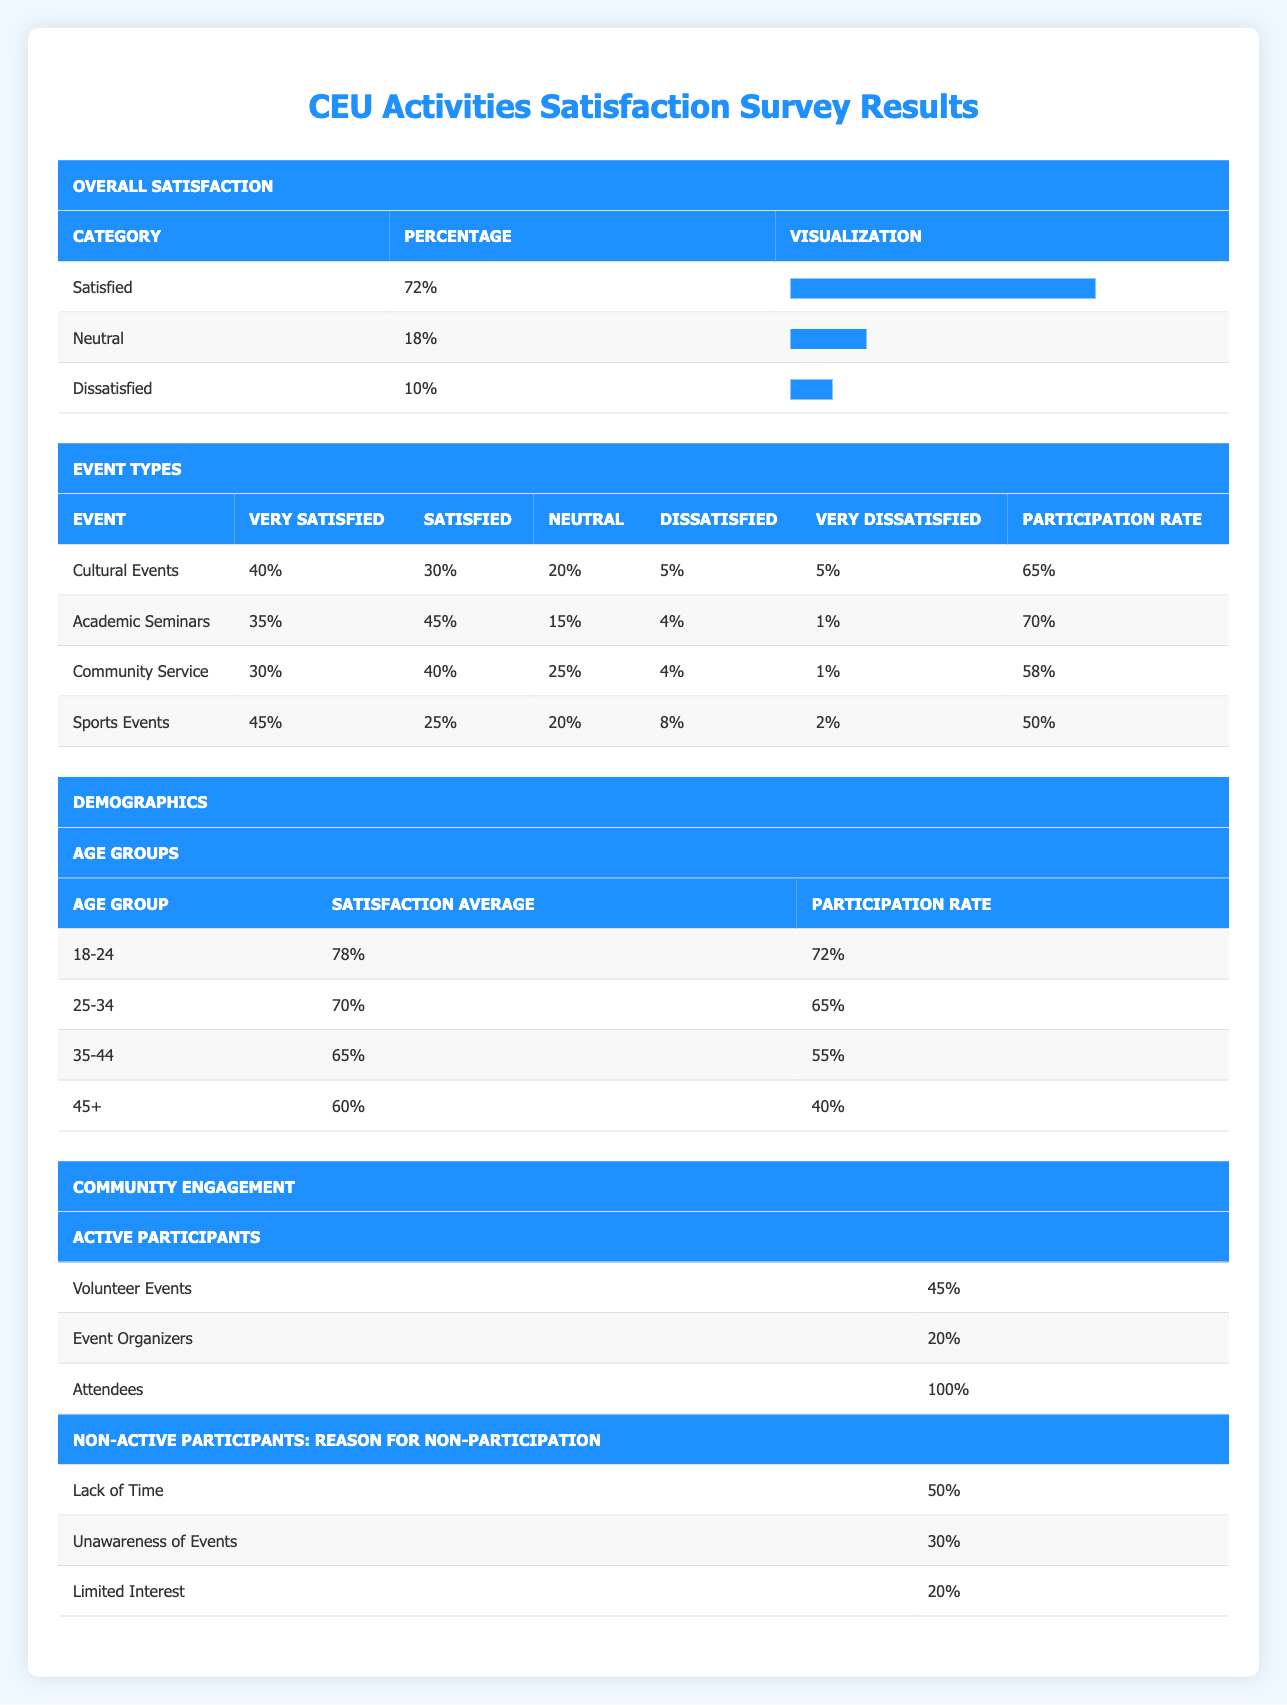What percentage of respondents were satisfied with CEU activities? According to the Overall Satisfaction section of the table, 72% of respondents reported being satisfied.
Answer: 72% What is the participation rate for Cultural Events? The Participation Rate for Cultural Events is listed as 65%.
Answer: 65% What is the average satisfaction for the 18-24 age group? The Satisfaction Average for the 18-24 age group is 78%, as stated under the Age Groups section.
Answer: 78% For which event type is the dissatisfaction percentage lowest? The Academic Seminars have the lowest dissatisfaction percentage at 5% (4% dissatisfied and 1% very dissatisfied).
Answer: Academic Seminars Is the participation rate for the 45+ age group higher than that for the 35-44 age group? The participation rate for the 45+ age group is 40%, while for the 35-44 age group, it is 55%. Therefore, the 45+ age group's participation rate is lower.
Answer: No What is the difference in the average satisfaction between the 18-24 age group and the 35-44 age group? The average satisfaction for the 18-24 age group is 78% and for the 35-44 age group is 65%. The difference is 78% - 65% = 13%.
Answer: 13% How many respondents cited 'Lack of Time' as the reason for non-participation? The Non-Active Participants section indicates that 50% cited 'Lack of Time' as the reason for not participating.
Answer: 50% What is the total participation rate of all active participants combined? Total participation cannot be simply summed from the provided percentages as they represent different categories. However, this specific data is not available for all active participants combined in percentage form.
Answer: Not applicable What is the overall percentage of respondents that indicated they are dissatisfied with CEU activities? The Overall Satisfaction section shows that 10% of respondents are dissatisfied (combining both dissatisfied and very dissatisfied).
Answer: 10% 